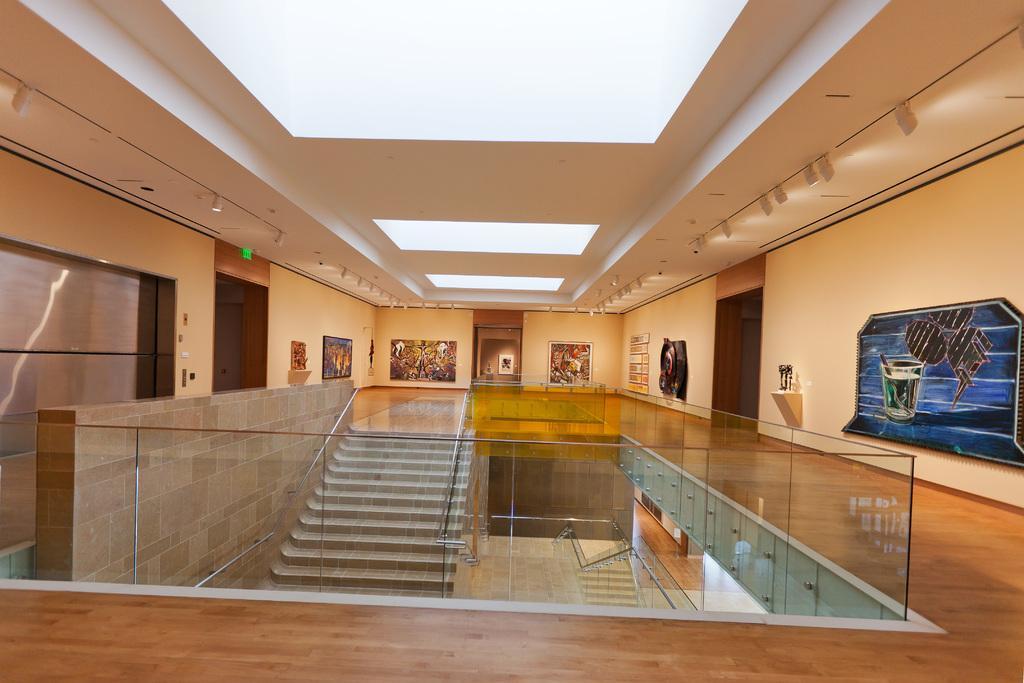Could you give a brief overview of what you see in this image? Here in this picture we can see glass railing covered over the place and in the middle we can see a stair case present and on the wall we can see some paintings and portraits present and on the roof we can see lights present and on the either side we can see doors present. 